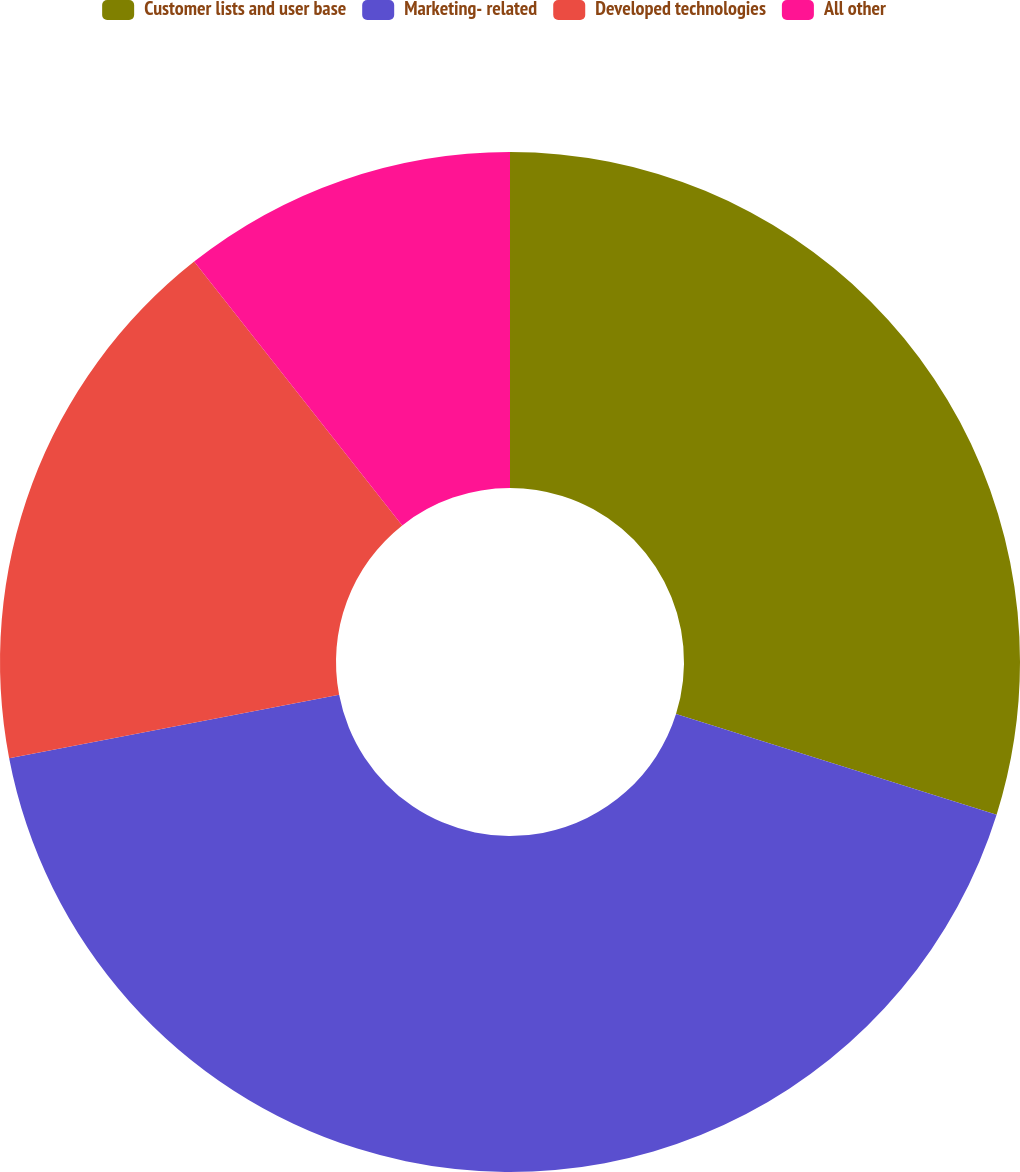<chart> <loc_0><loc_0><loc_500><loc_500><pie_chart><fcel>Customer lists and user base<fcel>Marketing- related<fcel>Developed technologies<fcel>All other<nl><fcel>29.84%<fcel>42.14%<fcel>17.39%<fcel>10.63%<nl></chart> 